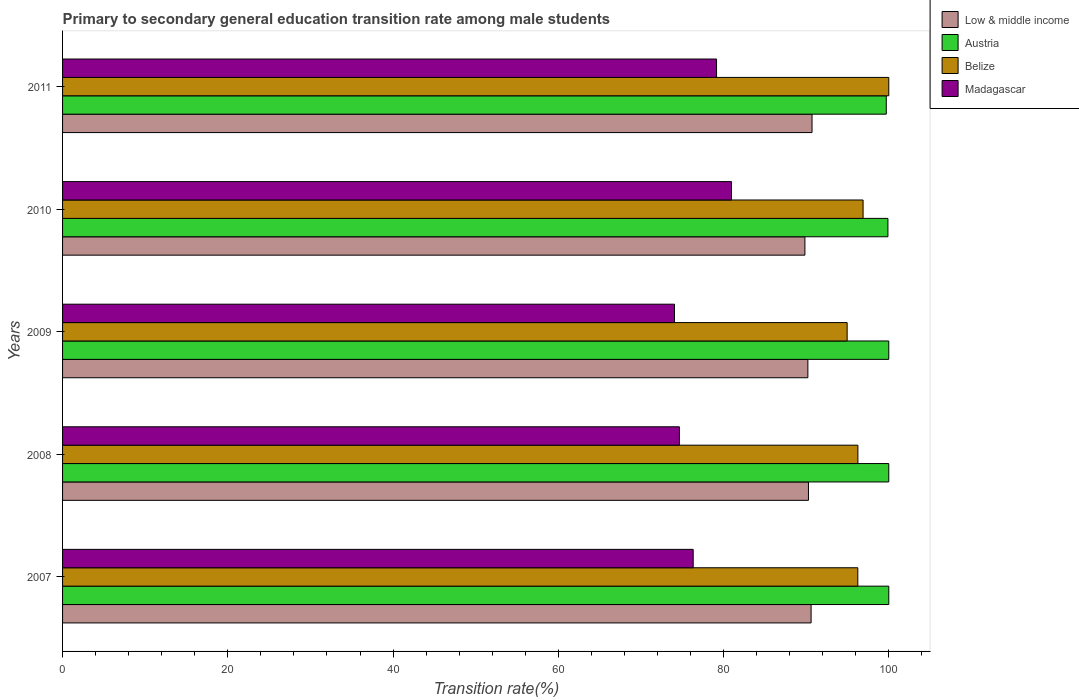How many groups of bars are there?
Make the answer very short. 5. How many bars are there on the 5th tick from the top?
Provide a short and direct response. 4. How many bars are there on the 3rd tick from the bottom?
Your answer should be very brief. 4. What is the label of the 5th group of bars from the top?
Your answer should be compact. 2007. What is the transition rate in Low & middle income in 2009?
Offer a terse response. 90.21. Across all years, what is the maximum transition rate in Low & middle income?
Make the answer very short. 90.71. Across all years, what is the minimum transition rate in Austria?
Give a very brief answer. 99.7. What is the total transition rate in Belize in the graph?
Your answer should be very brief. 484.37. What is the difference between the transition rate in Austria in 2007 and that in 2011?
Provide a succinct answer. 0.3. What is the difference between the transition rate in Belize in 2011 and the transition rate in Madagascar in 2007?
Your response must be concise. 23.67. What is the average transition rate in Austria per year?
Your answer should be compact. 99.92. In the year 2008, what is the difference between the transition rate in Madagascar and transition rate in Austria?
Ensure brevity in your answer.  -25.34. What is the ratio of the transition rate in Austria in 2007 to that in 2010?
Ensure brevity in your answer.  1. Is the transition rate in Madagascar in 2007 less than that in 2008?
Offer a very short reply. No. Is the difference between the transition rate in Madagascar in 2007 and 2009 greater than the difference between the transition rate in Austria in 2007 and 2009?
Make the answer very short. Yes. What is the difference between the highest and the second highest transition rate in Madagascar?
Your answer should be compact. 1.81. What is the difference between the highest and the lowest transition rate in Belize?
Offer a very short reply. 5.04. Is the sum of the transition rate in Madagascar in 2008 and 2011 greater than the maximum transition rate in Austria across all years?
Offer a very short reply. Yes. Is it the case that in every year, the sum of the transition rate in Low & middle income and transition rate in Madagascar is greater than the sum of transition rate in Austria and transition rate in Belize?
Your answer should be compact. No. What does the 3rd bar from the top in 2007 represents?
Give a very brief answer. Austria. What is the difference between two consecutive major ticks on the X-axis?
Make the answer very short. 20. Are the values on the major ticks of X-axis written in scientific E-notation?
Your response must be concise. No. Where does the legend appear in the graph?
Ensure brevity in your answer.  Top right. What is the title of the graph?
Your answer should be very brief. Primary to secondary general education transition rate among male students. What is the label or title of the X-axis?
Provide a succinct answer. Transition rate(%). What is the Transition rate(%) in Low & middle income in 2007?
Make the answer very short. 90.6. What is the Transition rate(%) in Belize in 2007?
Provide a succinct answer. 96.25. What is the Transition rate(%) of Madagascar in 2007?
Keep it short and to the point. 76.33. What is the Transition rate(%) in Low & middle income in 2008?
Keep it short and to the point. 90.28. What is the Transition rate(%) in Austria in 2008?
Your response must be concise. 100. What is the Transition rate(%) in Belize in 2008?
Your answer should be compact. 96.26. What is the Transition rate(%) in Madagascar in 2008?
Provide a succinct answer. 74.66. What is the Transition rate(%) in Low & middle income in 2009?
Offer a terse response. 90.21. What is the Transition rate(%) in Belize in 2009?
Your answer should be very brief. 94.96. What is the Transition rate(%) of Madagascar in 2009?
Your answer should be compact. 74.06. What is the Transition rate(%) in Low & middle income in 2010?
Ensure brevity in your answer.  89.85. What is the Transition rate(%) of Austria in 2010?
Your answer should be compact. 99.9. What is the Transition rate(%) of Belize in 2010?
Offer a very short reply. 96.89. What is the Transition rate(%) of Madagascar in 2010?
Offer a terse response. 80.96. What is the Transition rate(%) of Low & middle income in 2011?
Ensure brevity in your answer.  90.71. What is the Transition rate(%) of Austria in 2011?
Offer a terse response. 99.7. What is the Transition rate(%) in Belize in 2011?
Make the answer very short. 100. What is the Transition rate(%) in Madagascar in 2011?
Make the answer very short. 79.15. Across all years, what is the maximum Transition rate(%) of Low & middle income?
Your answer should be very brief. 90.71. Across all years, what is the maximum Transition rate(%) in Austria?
Offer a terse response. 100. Across all years, what is the maximum Transition rate(%) in Belize?
Offer a very short reply. 100. Across all years, what is the maximum Transition rate(%) of Madagascar?
Offer a terse response. 80.96. Across all years, what is the minimum Transition rate(%) in Low & middle income?
Provide a short and direct response. 89.85. Across all years, what is the minimum Transition rate(%) of Austria?
Provide a short and direct response. 99.7. Across all years, what is the minimum Transition rate(%) of Belize?
Give a very brief answer. 94.96. Across all years, what is the minimum Transition rate(%) in Madagascar?
Provide a short and direct response. 74.06. What is the total Transition rate(%) in Low & middle income in the graph?
Give a very brief answer. 451.64. What is the total Transition rate(%) in Austria in the graph?
Ensure brevity in your answer.  499.6. What is the total Transition rate(%) in Belize in the graph?
Give a very brief answer. 484.37. What is the total Transition rate(%) of Madagascar in the graph?
Make the answer very short. 385.17. What is the difference between the Transition rate(%) of Low & middle income in 2007 and that in 2008?
Make the answer very short. 0.32. What is the difference between the Transition rate(%) in Austria in 2007 and that in 2008?
Give a very brief answer. 0. What is the difference between the Transition rate(%) in Belize in 2007 and that in 2008?
Ensure brevity in your answer.  -0.01. What is the difference between the Transition rate(%) of Madagascar in 2007 and that in 2008?
Give a very brief answer. 1.67. What is the difference between the Transition rate(%) of Low & middle income in 2007 and that in 2009?
Your answer should be compact. 0.39. What is the difference between the Transition rate(%) in Austria in 2007 and that in 2009?
Your answer should be compact. 0. What is the difference between the Transition rate(%) in Belize in 2007 and that in 2009?
Your answer should be compact. 1.29. What is the difference between the Transition rate(%) in Madagascar in 2007 and that in 2009?
Make the answer very short. 2.26. What is the difference between the Transition rate(%) in Low & middle income in 2007 and that in 2010?
Provide a succinct answer. 0.75. What is the difference between the Transition rate(%) of Austria in 2007 and that in 2010?
Offer a very short reply. 0.1. What is the difference between the Transition rate(%) in Belize in 2007 and that in 2010?
Offer a very short reply. -0.64. What is the difference between the Transition rate(%) of Madagascar in 2007 and that in 2010?
Your answer should be compact. -4.64. What is the difference between the Transition rate(%) of Low & middle income in 2007 and that in 2011?
Provide a succinct answer. -0.11. What is the difference between the Transition rate(%) in Austria in 2007 and that in 2011?
Keep it short and to the point. 0.3. What is the difference between the Transition rate(%) of Belize in 2007 and that in 2011?
Your answer should be compact. -3.75. What is the difference between the Transition rate(%) of Madagascar in 2007 and that in 2011?
Provide a short and direct response. -2.83. What is the difference between the Transition rate(%) of Low & middle income in 2008 and that in 2009?
Make the answer very short. 0.07. What is the difference between the Transition rate(%) in Austria in 2008 and that in 2009?
Make the answer very short. 0. What is the difference between the Transition rate(%) of Belize in 2008 and that in 2009?
Your answer should be compact. 1.3. What is the difference between the Transition rate(%) in Madagascar in 2008 and that in 2009?
Keep it short and to the point. 0.59. What is the difference between the Transition rate(%) in Low & middle income in 2008 and that in 2010?
Keep it short and to the point. 0.43. What is the difference between the Transition rate(%) of Austria in 2008 and that in 2010?
Your answer should be compact. 0.1. What is the difference between the Transition rate(%) in Belize in 2008 and that in 2010?
Offer a very short reply. -0.63. What is the difference between the Transition rate(%) in Madagascar in 2008 and that in 2010?
Ensure brevity in your answer.  -6.3. What is the difference between the Transition rate(%) in Low & middle income in 2008 and that in 2011?
Your answer should be very brief. -0.43. What is the difference between the Transition rate(%) of Austria in 2008 and that in 2011?
Your response must be concise. 0.3. What is the difference between the Transition rate(%) of Belize in 2008 and that in 2011?
Give a very brief answer. -3.74. What is the difference between the Transition rate(%) of Madagascar in 2008 and that in 2011?
Ensure brevity in your answer.  -4.5. What is the difference between the Transition rate(%) of Low & middle income in 2009 and that in 2010?
Give a very brief answer. 0.36. What is the difference between the Transition rate(%) in Austria in 2009 and that in 2010?
Keep it short and to the point. 0.1. What is the difference between the Transition rate(%) of Belize in 2009 and that in 2010?
Provide a short and direct response. -1.93. What is the difference between the Transition rate(%) of Madagascar in 2009 and that in 2010?
Keep it short and to the point. -6.9. What is the difference between the Transition rate(%) in Low & middle income in 2009 and that in 2011?
Your response must be concise. -0.5. What is the difference between the Transition rate(%) of Austria in 2009 and that in 2011?
Make the answer very short. 0.3. What is the difference between the Transition rate(%) in Belize in 2009 and that in 2011?
Give a very brief answer. -5.04. What is the difference between the Transition rate(%) in Madagascar in 2009 and that in 2011?
Your answer should be very brief. -5.09. What is the difference between the Transition rate(%) in Low & middle income in 2010 and that in 2011?
Provide a succinct answer. -0.86. What is the difference between the Transition rate(%) of Austria in 2010 and that in 2011?
Keep it short and to the point. 0.2. What is the difference between the Transition rate(%) of Belize in 2010 and that in 2011?
Offer a terse response. -3.11. What is the difference between the Transition rate(%) of Madagascar in 2010 and that in 2011?
Keep it short and to the point. 1.81. What is the difference between the Transition rate(%) of Low & middle income in 2007 and the Transition rate(%) of Austria in 2008?
Ensure brevity in your answer.  -9.4. What is the difference between the Transition rate(%) in Low & middle income in 2007 and the Transition rate(%) in Belize in 2008?
Offer a very short reply. -5.66. What is the difference between the Transition rate(%) in Low & middle income in 2007 and the Transition rate(%) in Madagascar in 2008?
Your answer should be very brief. 15.94. What is the difference between the Transition rate(%) of Austria in 2007 and the Transition rate(%) of Belize in 2008?
Provide a short and direct response. 3.74. What is the difference between the Transition rate(%) of Austria in 2007 and the Transition rate(%) of Madagascar in 2008?
Provide a short and direct response. 25.34. What is the difference between the Transition rate(%) of Belize in 2007 and the Transition rate(%) of Madagascar in 2008?
Ensure brevity in your answer.  21.59. What is the difference between the Transition rate(%) in Low & middle income in 2007 and the Transition rate(%) in Austria in 2009?
Offer a very short reply. -9.4. What is the difference between the Transition rate(%) of Low & middle income in 2007 and the Transition rate(%) of Belize in 2009?
Provide a succinct answer. -4.36. What is the difference between the Transition rate(%) in Low & middle income in 2007 and the Transition rate(%) in Madagascar in 2009?
Offer a terse response. 16.53. What is the difference between the Transition rate(%) in Austria in 2007 and the Transition rate(%) in Belize in 2009?
Offer a terse response. 5.04. What is the difference between the Transition rate(%) in Austria in 2007 and the Transition rate(%) in Madagascar in 2009?
Your response must be concise. 25.94. What is the difference between the Transition rate(%) in Belize in 2007 and the Transition rate(%) in Madagascar in 2009?
Give a very brief answer. 22.19. What is the difference between the Transition rate(%) of Low & middle income in 2007 and the Transition rate(%) of Austria in 2010?
Your answer should be compact. -9.3. What is the difference between the Transition rate(%) in Low & middle income in 2007 and the Transition rate(%) in Belize in 2010?
Provide a succinct answer. -6.29. What is the difference between the Transition rate(%) of Low & middle income in 2007 and the Transition rate(%) of Madagascar in 2010?
Keep it short and to the point. 9.63. What is the difference between the Transition rate(%) of Austria in 2007 and the Transition rate(%) of Belize in 2010?
Offer a very short reply. 3.11. What is the difference between the Transition rate(%) of Austria in 2007 and the Transition rate(%) of Madagascar in 2010?
Your answer should be compact. 19.04. What is the difference between the Transition rate(%) of Belize in 2007 and the Transition rate(%) of Madagascar in 2010?
Ensure brevity in your answer.  15.29. What is the difference between the Transition rate(%) of Low & middle income in 2007 and the Transition rate(%) of Austria in 2011?
Ensure brevity in your answer.  -9.1. What is the difference between the Transition rate(%) in Low & middle income in 2007 and the Transition rate(%) in Belize in 2011?
Offer a terse response. -9.4. What is the difference between the Transition rate(%) of Low & middle income in 2007 and the Transition rate(%) of Madagascar in 2011?
Offer a terse response. 11.44. What is the difference between the Transition rate(%) of Austria in 2007 and the Transition rate(%) of Belize in 2011?
Your response must be concise. 0. What is the difference between the Transition rate(%) in Austria in 2007 and the Transition rate(%) in Madagascar in 2011?
Keep it short and to the point. 20.85. What is the difference between the Transition rate(%) in Belize in 2007 and the Transition rate(%) in Madagascar in 2011?
Ensure brevity in your answer.  17.1. What is the difference between the Transition rate(%) in Low & middle income in 2008 and the Transition rate(%) in Austria in 2009?
Provide a succinct answer. -9.72. What is the difference between the Transition rate(%) in Low & middle income in 2008 and the Transition rate(%) in Belize in 2009?
Your answer should be compact. -4.68. What is the difference between the Transition rate(%) of Low & middle income in 2008 and the Transition rate(%) of Madagascar in 2009?
Provide a short and direct response. 16.22. What is the difference between the Transition rate(%) in Austria in 2008 and the Transition rate(%) in Belize in 2009?
Provide a short and direct response. 5.04. What is the difference between the Transition rate(%) in Austria in 2008 and the Transition rate(%) in Madagascar in 2009?
Offer a very short reply. 25.94. What is the difference between the Transition rate(%) in Belize in 2008 and the Transition rate(%) in Madagascar in 2009?
Offer a terse response. 22.2. What is the difference between the Transition rate(%) in Low & middle income in 2008 and the Transition rate(%) in Austria in 2010?
Offer a terse response. -9.62. What is the difference between the Transition rate(%) in Low & middle income in 2008 and the Transition rate(%) in Belize in 2010?
Keep it short and to the point. -6.61. What is the difference between the Transition rate(%) of Low & middle income in 2008 and the Transition rate(%) of Madagascar in 2010?
Your response must be concise. 9.32. What is the difference between the Transition rate(%) of Austria in 2008 and the Transition rate(%) of Belize in 2010?
Provide a succinct answer. 3.11. What is the difference between the Transition rate(%) in Austria in 2008 and the Transition rate(%) in Madagascar in 2010?
Offer a very short reply. 19.04. What is the difference between the Transition rate(%) in Belize in 2008 and the Transition rate(%) in Madagascar in 2010?
Offer a very short reply. 15.3. What is the difference between the Transition rate(%) of Low & middle income in 2008 and the Transition rate(%) of Austria in 2011?
Offer a terse response. -9.42. What is the difference between the Transition rate(%) in Low & middle income in 2008 and the Transition rate(%) in Belize in 2011?
Your answer should be very brief. -9.72. What is the difference between the Transition rate(%) of Low & middle income in 2008 and the Transition rate(%) of Madagascar in 2011?
Ensure brevity in your answer.  11.12. What is the difference between the Transition rate(%) of Austria in 2008 and the Transition rate(%) of Madagascar in 2011?
Keep it short and to the point. 20.85. What is the difference between the Transition rate(%) in Belize in 2008 and the Transition rate(%) in Madagascar in 2011?
Keep it short and to the point. 17.11. What is the difference between the Transition rate(%) of Low & middle income in 2009 and the Transition rate(%) of Austria in 2010?
Provide a succinct answer. -9.69. What is the difference between the Transition rate(%) of Low & middle income in 2009 and the Transition rate(%) of Belize in 2010?
Ensure brevity in your answer.  -6.68. What is the difference between the Transition rate(%) in Low & middle income in 2009 and the Transition rate(%) in Madagascar in 2010?
Offer a terse response. 9.24. What is the difference between the Transition rate(%) of Austria in 2009 and the Transition rate(%) of Belize in 2010?
Ensure brevity in your answer.  3.11. What is the difference between the Transition rate(%) in Austria in 2009 and the Transition rate(%) in Madagascar in 2010?
Offer a very short reply. 19.04. What is the difference between the Transition rate(%) of Belize in 2009 and the Transition rate(%) of Madagascar in 2010?
Ensure brevity in your answer.  14. What is the difference between the Transition rate(%) in Low & middle income in 2009 and the Transition rate(%) in Austria in 2011?
Your answer should be very brief. -9.49. What is the difference between the Transition rate(%) in Low & middle income in 2009 and the Transition rate(%) in Belize in 2011?
Offer a terse response. -9.79. What is the difference between the Transition rate(%) of Low & middle income in 2009 and the Transition rate(%) of Madagascar in 2011?
Make the answer very short. 11.05. What is the difference between the Transition rate(%) of Austria in 2009 and the Transition rate(%) of Madagascar in 2011?
Offer a very short reply. 20.85. What is the difference between the Transition rate(%) in Belize in 2009 and the Transition rate(%) in Madagascar in 2011?
Provide a succinct answer. 15.81. What is the difference between the Transition rate(%) of Low & middle income in 2010 and the Transition rate(%) of Austria in 2011?
Give a very brief answer. -9.85. What is the difference between the Transition rate(%) of Low & middle income in 2010 and the Transition rate(%) of Belize in 2011?
Provide a short and direct response. -10.15. What is the difference between the Transition rate(%) in Low & middle income in 2010 and the Transition rate(%) in Madagascar in 2011?
Your response must be concise. 10.69. What is the difference between the Transition rate(%) of Austria in 2010 and the Transition rate(%) of Belize in 2011?
Provide a succinct answer. -0.1. What is the difference between the Transition rate(%) of Austria in 2010 and the Transition rate(%) of Madagascar in 2011?
Keep it short and to the point. 20.74. What is the difference between the Transition rate(%) in Belize in 2010 and the Transition rate(%) in Madagascar in 2011?
Your answer should be compact. 17.74. What is the average Transition rate(%) in Low & middle income per year?
Ensure brevity in your answer.  90.33. What is the average Transition rate(%) in Austria per year?
Make the answer very short. 99.92. What is the average Transition rate(%) in Belize per year?
Ensure brevity in your answer.  96.87. What is the average Transition rate(%) in Madagascar per year?
Provide a short and direct response. 77.03. In the year 2007, what is the difference between the Transition rate(%) of Low & middle income and Transition rate(%) of Austria?
Offer a terse response. -9.4. In the year 2007, what is the difference between the Transition rate(%) of Low & middle income and Transition rate(%) of Belize?
Your answer should be compact. -5.66. In the year 2007, what is the difference between the Transition rate(%) of Low & middle income and Transition rate(%) of Madagascar?
Provide a short and direct response. 14.27. In the year 2007, what is the difference between the Transition rate(%) in Austria and Transition rate(%) in Belize?
Offer a very short reply. 3.75. In the year 2007, what is the difference between the Transition rate(%) of Austria and Transition rate(%) of Madagascar?
Provide a succinct answer. 23.67. In the year 2007, what is the difference between the Transition rate(%) in Belize and Transition rate(%) in Madagascar?
Give a very brief answer. 19.93. In the year 2008, what is the difference between the Transition rate(%) in Low & middle income and Transition rate(%) in Austria?
Provide a succinct answer. -9.72. In the year 2008, what is the difference between the Transition rate(%) of Low & middle income and Transition rate(%) of Belize?
Ensure brevity in your answer.  -5.98. In the year 2008, what is the difference between the Transition rate(%) in Low & middle income and Transition rate(%) in Madagascar?
Your answer should be compact. 15.62. In the year 2008, what is the difference between the Transition rate(%) in Austria and Transition rate(%) in Belize?
Your answer should be compact. 3.74. In the year 2008, what is the difference between the Transition rate(%) of Austria and Transition rate(%) of Madagascar?
Offer a terse response. 25.34. In the year 2008, what is the difference between the Transition rate(%) in Belize and Transition rate(%) in Madagascar?
Provide a short and direct response. 21.6. In the year 2009, what is the difference between the Transition rate(%) in Low & middle income and Transition rate(%) in Austria?
Ensure brevity in your answer.  -9.79. In the year 2009, what is the difference between the Transition rate(%) in Low & middle income and Transition rate(%) in Belize?
Provide a succinct answer. -4.75. In the year 2009, what is the difference between the Transition rate(%) in Low & middle income and Transition rate(%) in Madagascar?
Your answer should be very brief. 16.14. In the year 2009, what is the difference between the Transition rate(%) of Austria and Transition rate(%) of Belize?
Offer a terse response. 5.04. In the year 2009, what is the difference between the Transition rate(%) of Austria and Transition rate(%) of Madagascar?
Make the answer very short. 25.94. In the year 2009, what is the difference between the Transition rate(%) of Belize and Transition rate(%) of Madagascar?
Give a very brief answer. 20.9. In the year 2010, what is the difference between the Transition rate(%) of Low & middle income and Transition rate(%) of Austria?
Offer a terse response. -10.05. In the year 2010, what is the difference between the Transition rate(%) of Low & middle income and Transition rate(%) of Belize?
Keep it short and to the point. -7.04. In the year 2010, what is the difference between the Transition rate(%) in Low & middle income and Transition rate(%) in Madagascar?
Offer a terse response. 8.89. In the year 2010, what is the difference between the Transition rate(%) in Austria and Transition rate(%) in Belize?
Make the answer very short. 3.01. In the year 2010, what is the difference between the Transition rate(%) in Austria and Transition rate(%) in Madagascar?
Make the answer very short. 18.93. In the year 2010, what is the difference between the Transition rate(%) of Belize and Transition rate(%) of Madagascar?
Offer a terse response. 15.93. In the year 2011, what is the difference between the Transition rate(%) in Low & middle income and Transition rate(%) in Austria?
Your answer should be very brief. -8.99. In the year 2011, what is the difference between the Transition rate(%) of Low & middle income and Transition rate(%) of Belize?
Offer a terse response. -9.29. In the year 2011, what is the difference between the Transition rate(%) in Low & middle income and Transition rate(%) in Madagascar?
Keep it short and to the point. 11.56. In the year 2011, what is the difference between the Transition rate(%) in Austria and Transition rate(%) in Belize?
Offer a very short reply. -0.3. In the year 2011, what is the difference between the Transition rate(%) in Austria and Transition rate(%) in Madagascar?
Provide a succinct answer. 20.54. In the year 2011, what is the difference between the Transition rate(%) of Belize and Transition rate(%) of Madagascar?
Offer a terse response. 20.85. What is the ratio of the Transition rate(%) in Austria in 2007 to that in 2008?
Offer a terse response. 1. What is the ratio of the Transition rate(%) of Madagascar in 2007 to that in 2008?
Give a very brief answer. 1.02. What is the ratio of the Transition rate(%) of Belize in 2007 to that in 2009?
Keep it short and to the point. 1.01. What is the ratio of the Transition rate(%) of Madagascar in 2007 to that in 2009?
Provide a short and direct response. 1.03. What is the ratio of the Transition rate(%) in Low & middle income in 2007 to that in 2010?
Offer a very short reply. 1.01. What is the ratio of the Transition rate(%) in Austria in 2007 to that in 2010?
Give a very brief answer. 1. What is the ratio of the Transition rate(%) of Madagascar in 2007 to that in 2010?
Your answer should be very brief. 0.94. What is the ratio of the Transition rate(%) in Belize in 2007 to that in 2011?
Your answer should be very brief. 0.96. What is the ratio of the Transition rate(%) of Belize in 2008 to that in 2009?
Provide a short and direct response. 1.01. What is the ratio of the Transition rate(%) of Madagascar in 2008 to that in 2009?
Offer a very short reply. 1.01. What is the ratio of the Transition rate(%) in Austria in 2008 to that in 2010?
Ensure brevity in your answer.  1. What is the ratio of the Transition rate(%) of Madagascar in 2008 to that in 2010?
Your response must be concise. 0.92. What is the ratio of the Transition rate(%) of Low & middle income in 2008 to that in 2011?
Provide a succinct answer. 1. What is the ratio of the Transition rate(%) of Belize in 2008 to that in 2011?
Provide a short and direct response. 0.96. What is the ratio of the Transition rate(%) in Madagascar in 2008 to that in 2011?
Your response must be concise. 0.94. What is the ratio of the Transition rate(%) of Austria in 2009 to that in 2010?
Provide a succinct answer. 1. What is the ratio of the Transition rate(%) of Belize in 2009 to that in 2010?
Provide a succinct answer. 0.98. What is the ratio of the Transition rate(%) in Madagascar in 2009 to that in 2010?
Offer a terse response. 0.91. What is the ratio of the Transition rate(%) in Belize in 2009 to that in 2011?
Give a very brief answer. 0.95. What is the ratio of the Transition rate(%) in Madagascar in 2009 to that in 2011?
Offer a terse response. 0.94. What is the ratio of the Transition rate(%) in Austria in 2010 to that in 2011?
Provide a short and direct response. 1. What is the ratio of the Transition rate(%) in Belize in 2010 to that in 2011?
Ensure brevity in your answer.  0.97. What is the ratio of the Transition rate(%) in Madagascar in 2010 to that in 2011?
Provide a short and direct response. 1.02. What is the difference between the highest and the second highest Transition rate(%) of Low & middle income?
Your answer should be very brief. 0.11. What is the difference between the highest and the second highest Transition rate(%) in Austria?
Offer a very short reply. 0. What is the difference between the highest and the second highest Transition rate(%) of Belize?
Your answer should be very brief. 3.11. What is the difference between the highest and the second highest Transition rate(%) of Madagascar?
Provide a short and direct response. 1.81. What is the difference between the highest and the lowest Transition rate(%) in Low & middle income?
Your response must be concise. 0.86. What is the difference between the highest and the lowest Transition rate(%) in Austria?
Give a very brief answer. 0.3. What is the difference between the highest and the lowest Transition rate(%) in Belize?
Give a very brief answer. 5.04. What is the difference between the highest and the lowest Transition rate(%) of Madagascar?
Give a very brief answer. 6.9. 